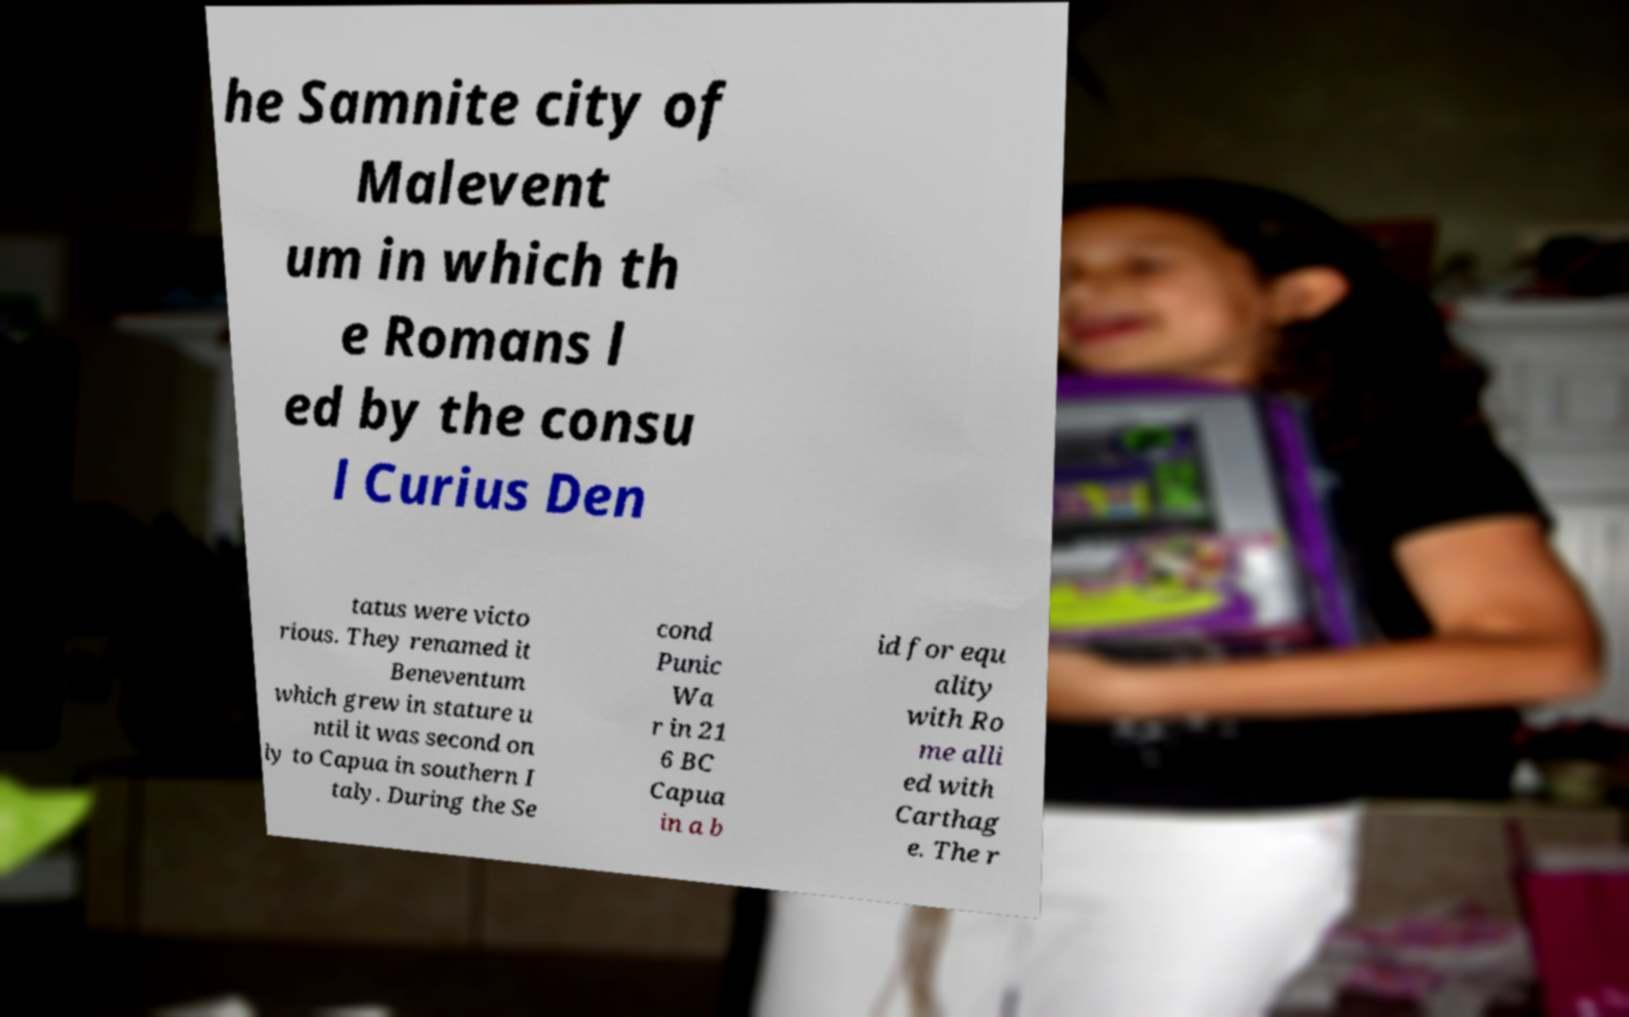For documentation purposes, I need the text within this image transcribed. Could you provide that? he Samnite city of Malevent um in which th e Romans l ed by the consu l Curius Den tatus were victo rious. They renamed it Beneventum which grew in stature u ntil it was second on ly to Capua in southern I taly. During the Se cond Punic Wa r in 21 6 BC Capua in a b id for equ ality with Ro me alli ed with Carthag e. The r 